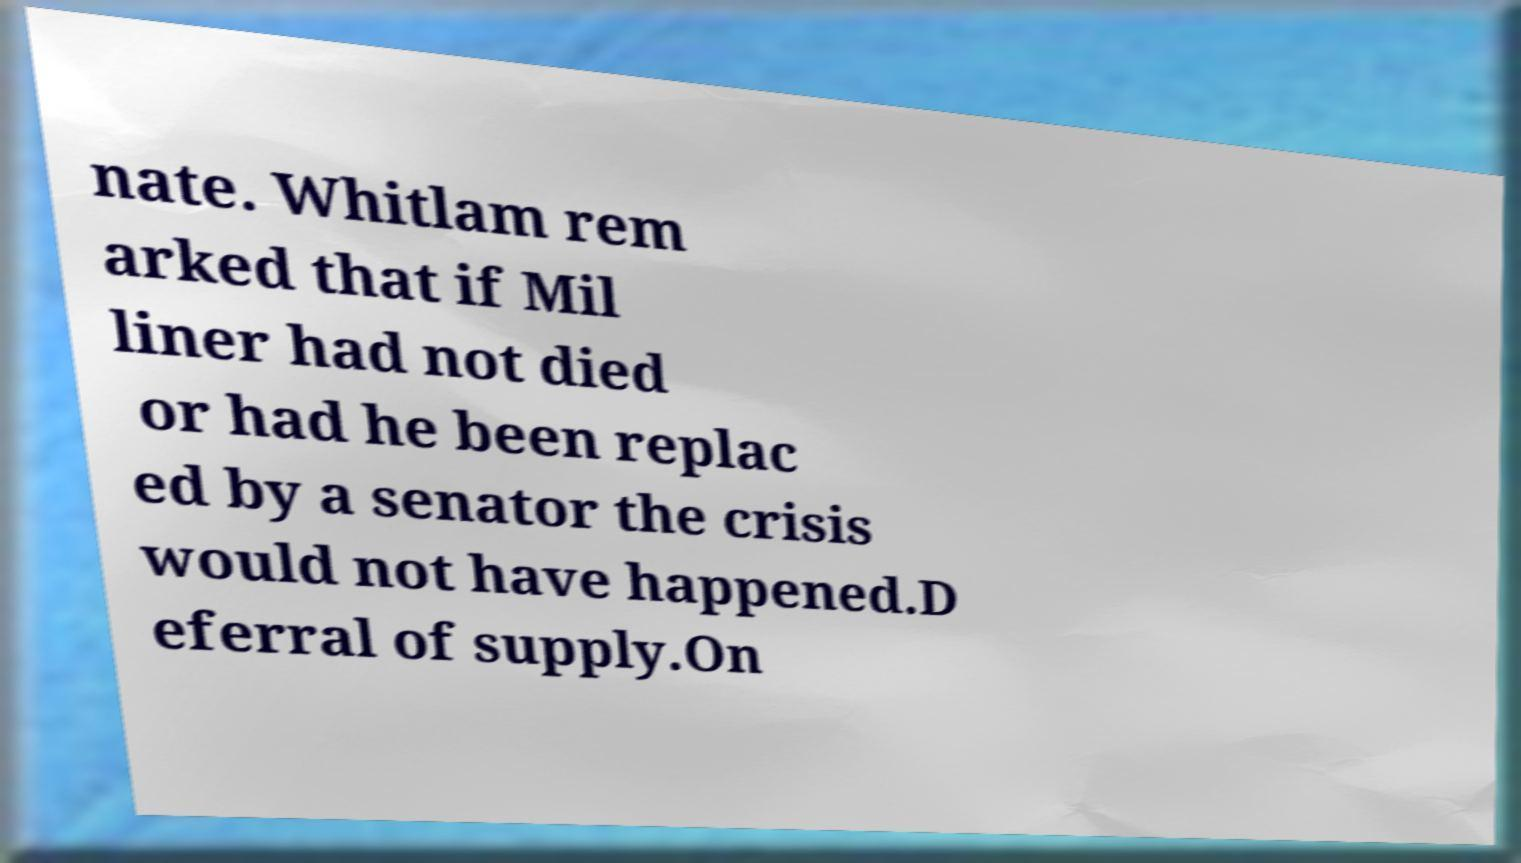Can you accurately transcribe the text from the provided image for me? nate. Whitlam rem arked that if Mil liner had not died or had he been replac ed by a senator the crisis would not have happened.D eferral of supply.On 